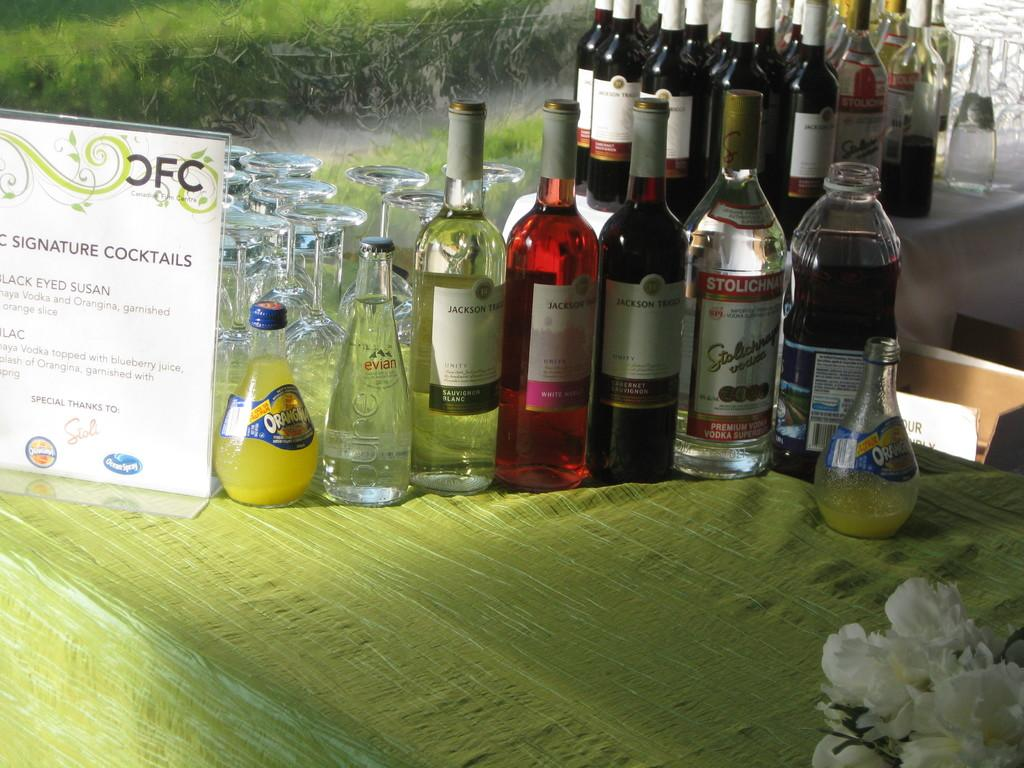<image>
Write a terse but informative summary of the picture. A table with bottles of alcohol on it with a sign saying signature cocktails. 